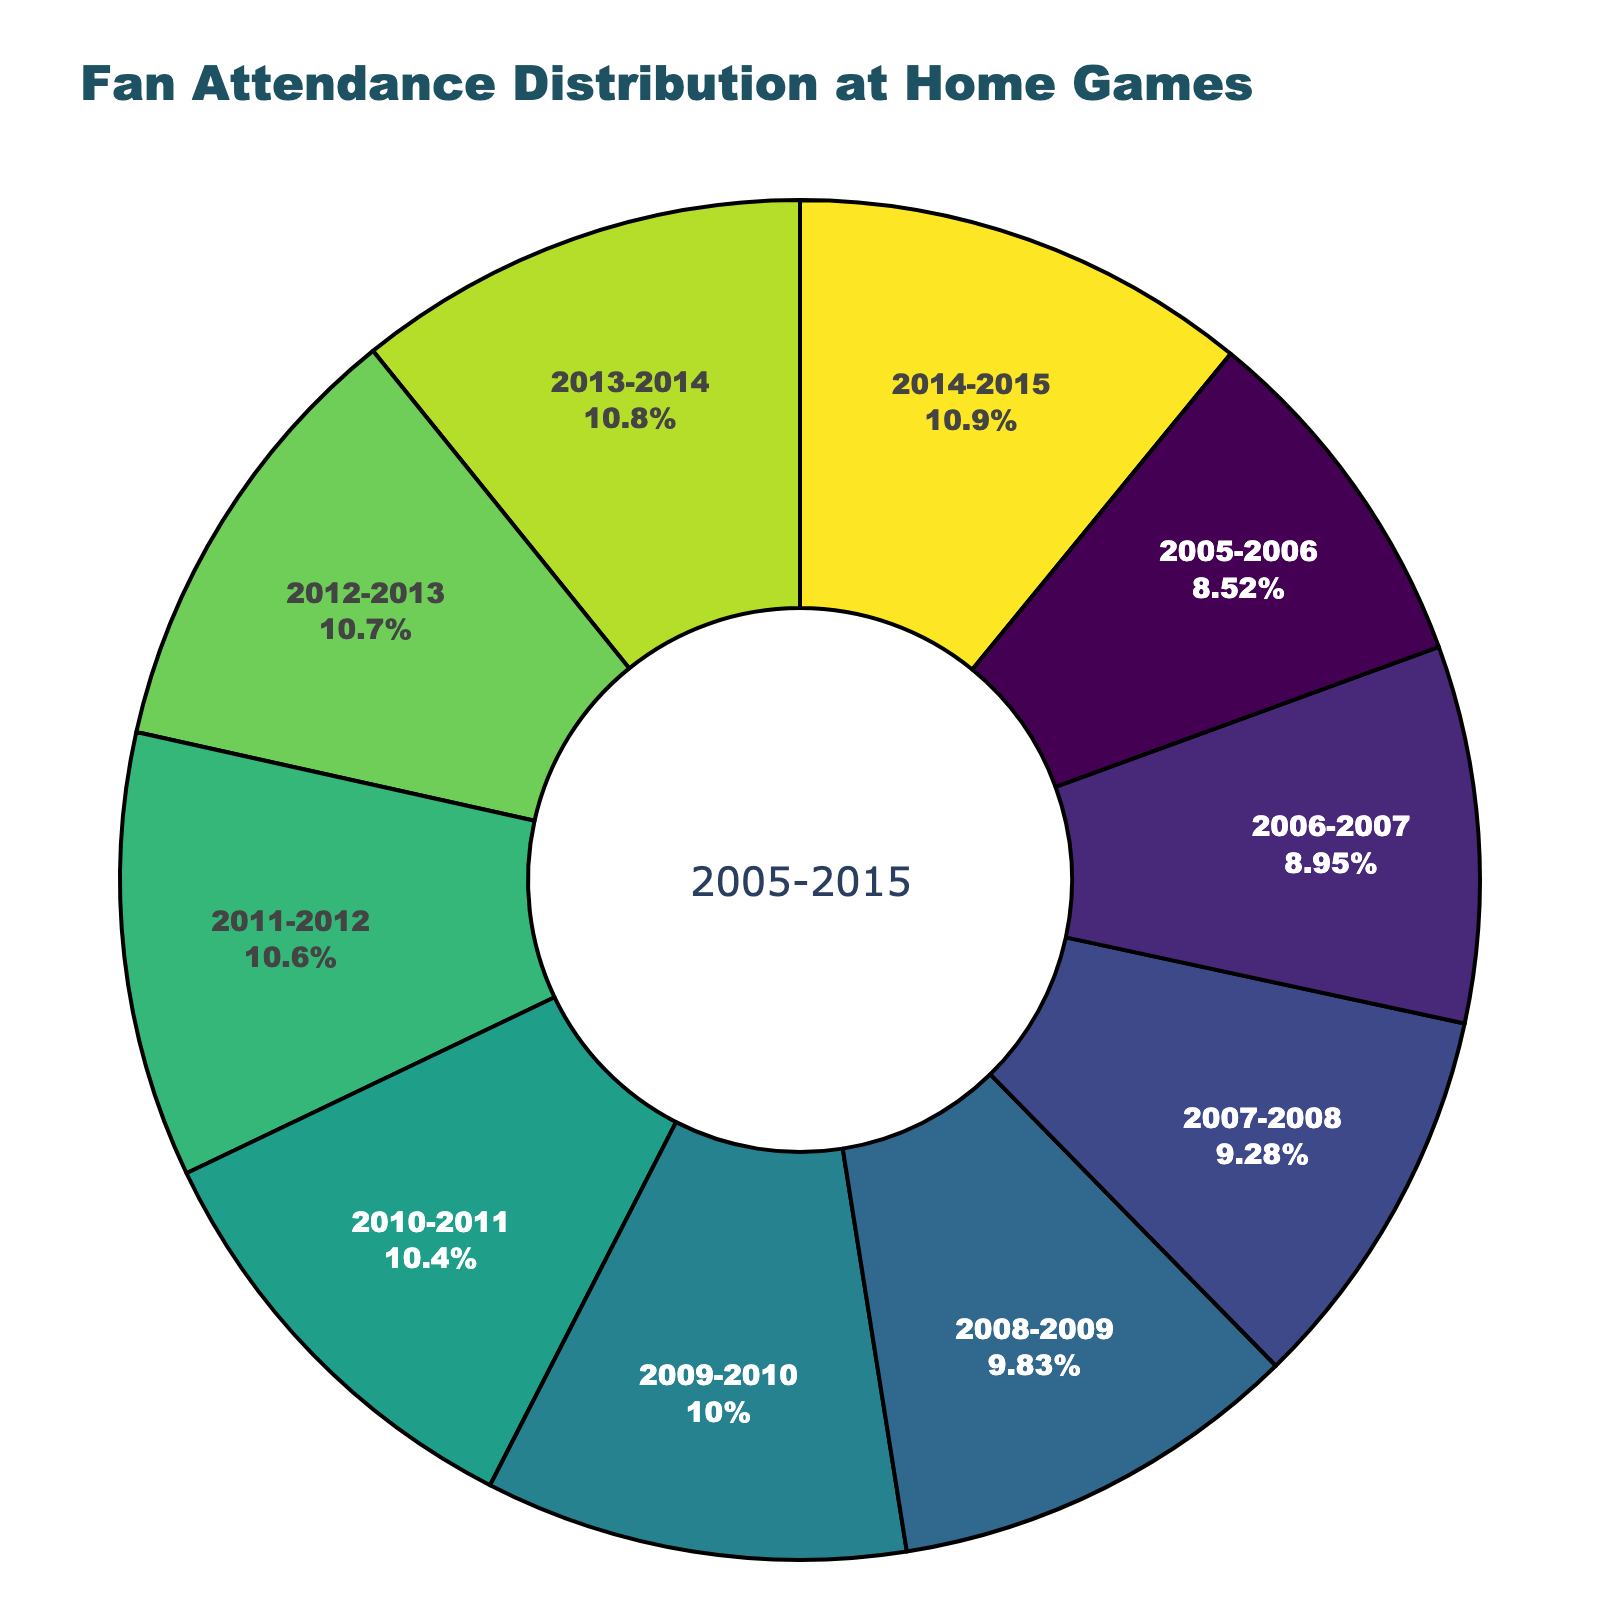How does the 2005-2006 season's attendance percentage compare to the 2014-2015 season's? The 2005-2006 season's attendance percentage is 78%, while the 2014-2015 season's attendance percentage is 100%. Comparing these values, the 2014-2015 season has a higher attendance percentage.
Answer: 2014-2015 is higher Which season had the lowest attendance percentage? By looking at the pie chart, the 2005-2006 season has the lowest attendance percentage at 78%.
Answer: 2005-2006 How much did the attendance percentage increase from the 2005-2006 season to the 2010-2011 season? The attendance percentage in the 2005-2006 season is 78% and in the 2010-2011 season it is 95%. The increase is calculated as 95% - 78% = 17%.
Answer: 17% What is the average attendance percentage over all the seasons shown? The total attendance percentage over the 10 seasons is the sum of the percentages. (78 + 82 + 85 + 90 + 92 + 95 + 97 + 98 + 99 + 100) / 10 = 916 / 10 = 91.6%.
Answer: 91.6% Which season saw an attendance percentage equal to or above 95% for the first time? The pie chart shows that the 2010-2011 season is the first season to have an attendance percentage of 95% or more.
Answer: 2010-2011 What is the difference in the attendance percentage between the 2007-2008 season and the 2008-2009 season? The 2007-2008 season has an attendance percentage of 85% and the 2008-2009 season has 90%. The difference is calculated as 90% - 85% = 5%.
Answer: 5% From which season onwards did the attendance percentage remain consistently above 90%? The attendance percentage is above 90% from the 2009-2010 season through to the 2014-2015 season.
Answer: 2009-2010 onward Which two adjacent seasons had the smallest increase in attendance percentage? By examining the chart, the smallest increase between two adjacent seasons is between the 2012-2013 (98%) and 2013-2014 (99%) seasons. The increase is 99% - 98% = 1%.
Answer: 2012-2013 and 2013-2014 How many seasons had an attendance percentage of 97% or more? From the visual information, the 2011-2012 (97%), 2012-2013 (98%), 2013-2014 (99%), and 2014-2015 (100%) had 97% or more attendance. This makes 4 seasons.
Answer: 4 